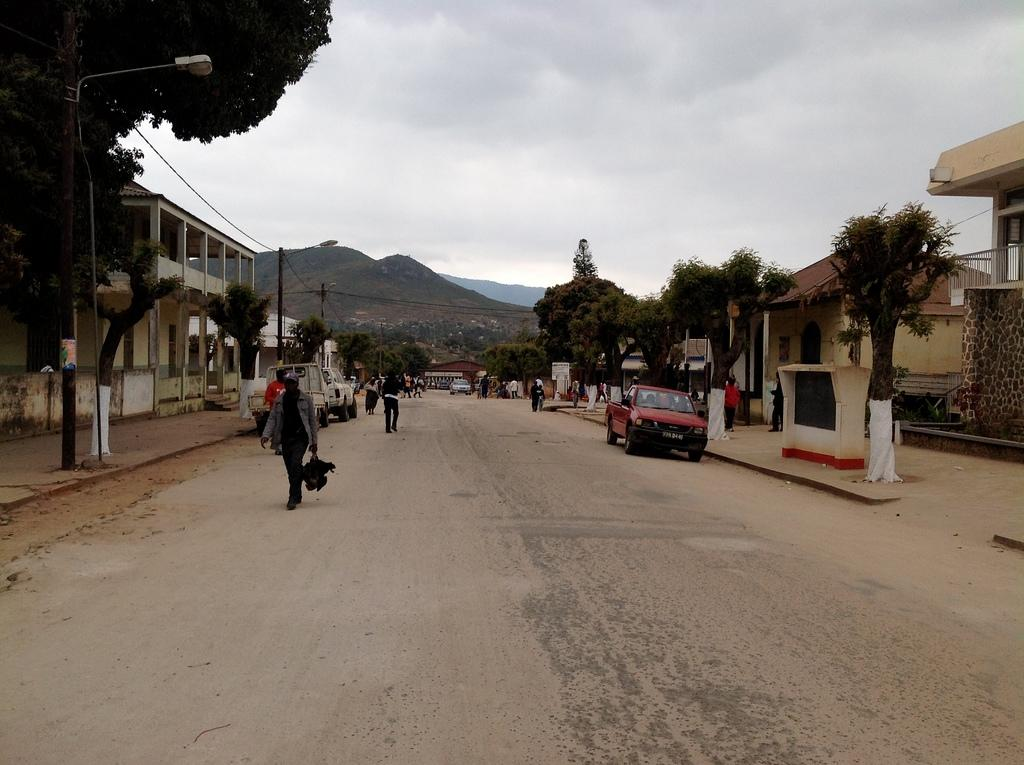What is the main feature of the image? There is a road in the image. What else can be seen on the road? There are vehicles in the image. Are there any people present in the image? Yes, there are people in the image. What else can be seen in the image besides the road, vehicles, and people? There are poles, wires, trees, lights, houses, and a mountain in the background of the image. What is the condition of the sky in the background? The sky in the background has clouds. How many beggars are visible in the image? There are no beggars present in the image. What type of transport is being used by the people in the image? The vehicles in the image are the mode of transport for the people, but we cannot determine the specific type of transport from the image. 